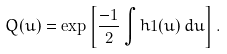Convert formula to latex. <formula><loc_0><loc_0><loc_500><loc_500>Q ( u ) = \exp \left [ \frac { - 1 } { 2 } \int h 1 ( u ) \, d u \right ] .</formula> 